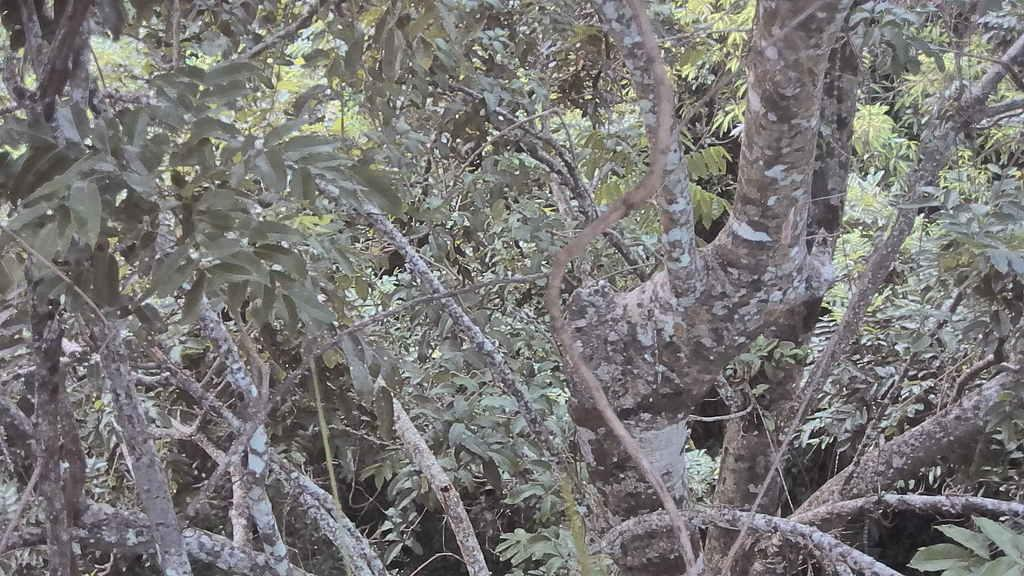What is the primary feature of the image? The primary feature of the image is the presence of many trees. What can be said about the color of the trees? The trees are green in color. How often does the cub visit the trees in the image? There is no mention of a cub in the image, so it is impossible to determine how often it visits the trees. 